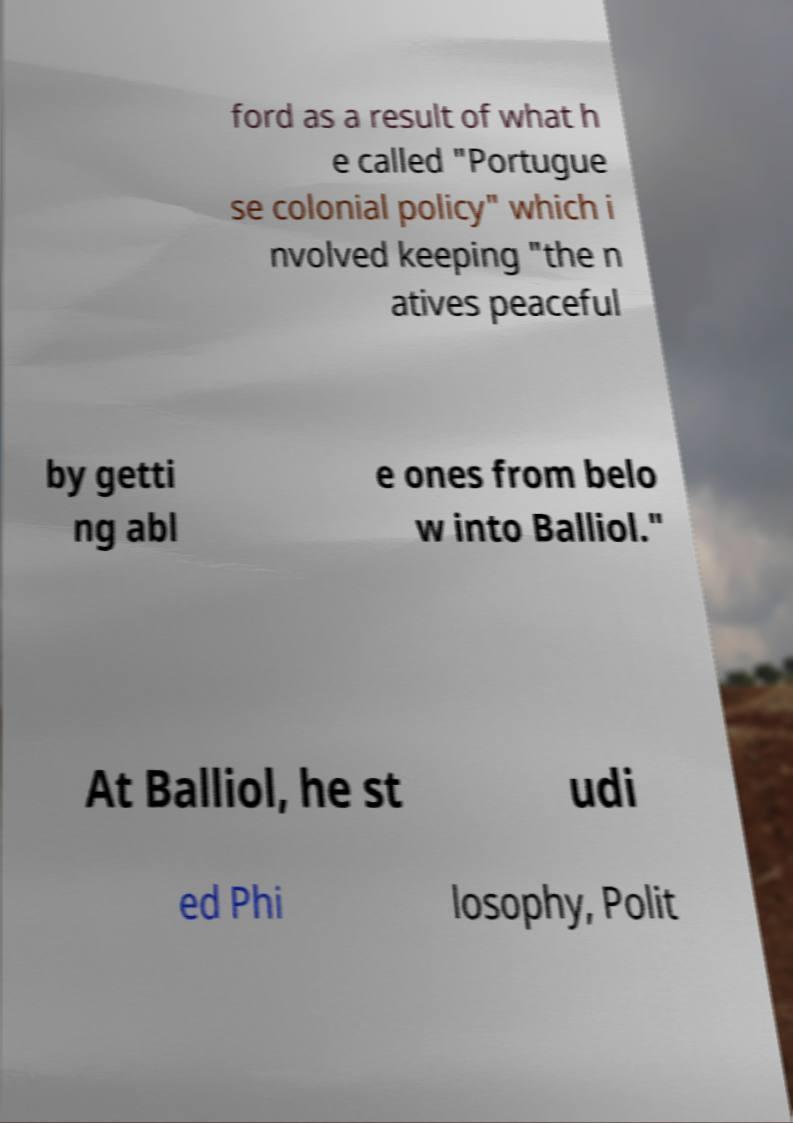Can you accurately transcribe the text from the provided image for me? ford as a result of what h e called "Portugue se colonial policy" which i nvolved keeping "the n atives peaceful by getti ng abl e ones from belo w into Balliol." At Balliol, he st udi ed Phi losophy, Polit 